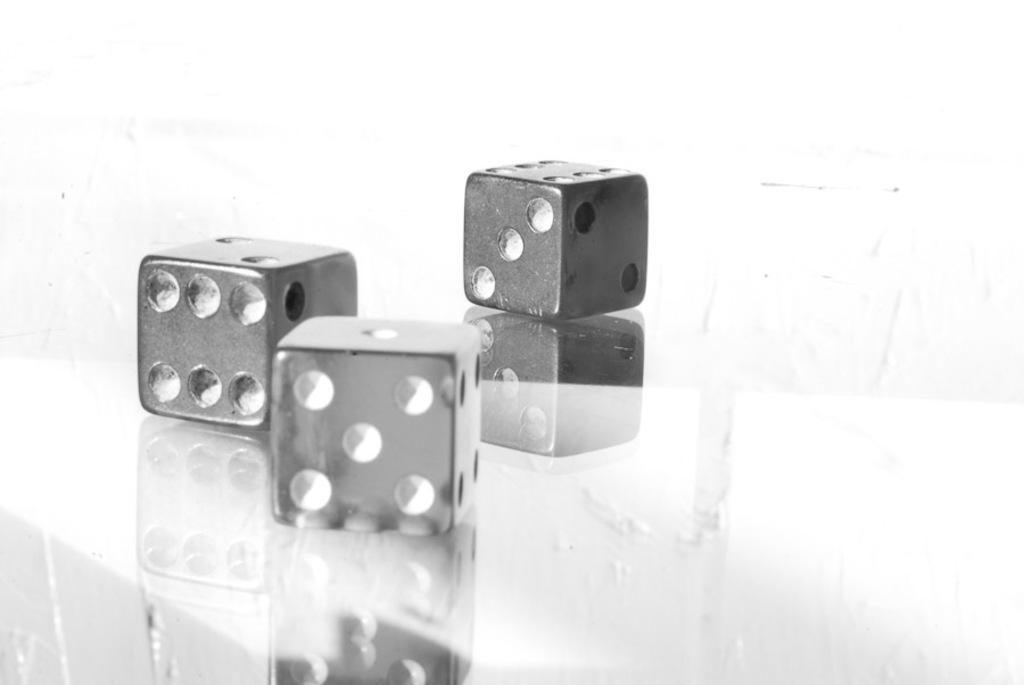What objects are in the middle of the image? There are three dice in the middle of the image. What is the color of the background in the image? The background of the image is white. What is the size of the airport in the image? There is no airport present in the image; it features three dice on a white background. 